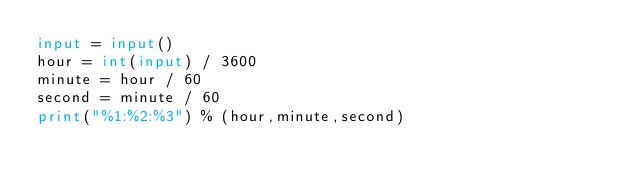Convert code to text. <code><loc_0><loc_0><loc_500><loc_500><_Python_>input = input()
hour = int(input) / 3600
minute = hour / 60
second = minute / 60
print("%1:%2:%3") % (hour,minute,second)</code> 